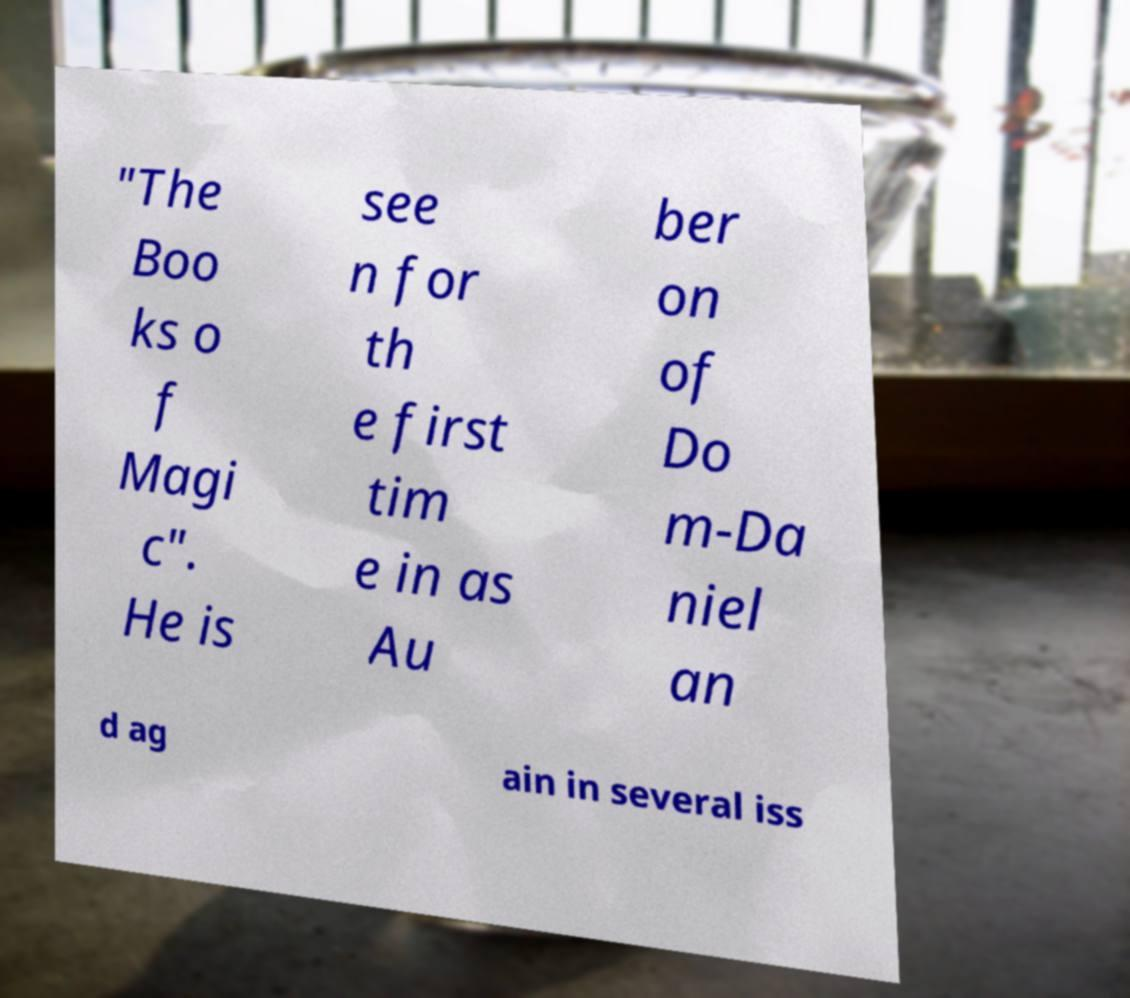Could you extract and type out the text from this image? "The Boo ks o f Magi c". He is see n for th e first tim e in as Au ber on of Do m-Da niel an d ag ain in several iss 